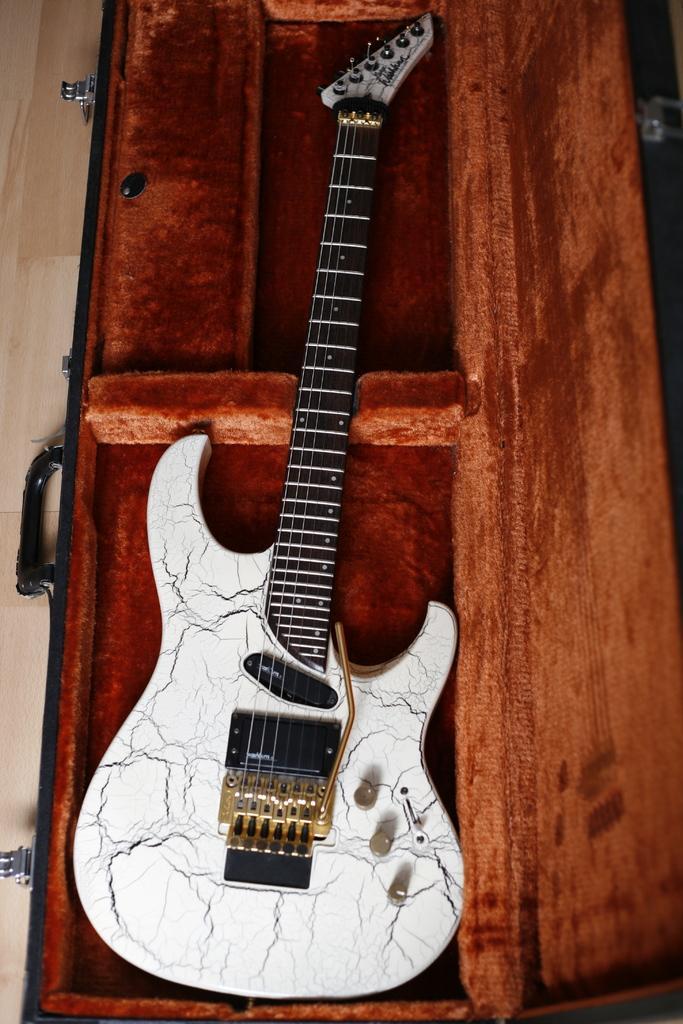Describe this image in one or two sentences. In this image there is a white color guitar kept in a wooden guitar case. 